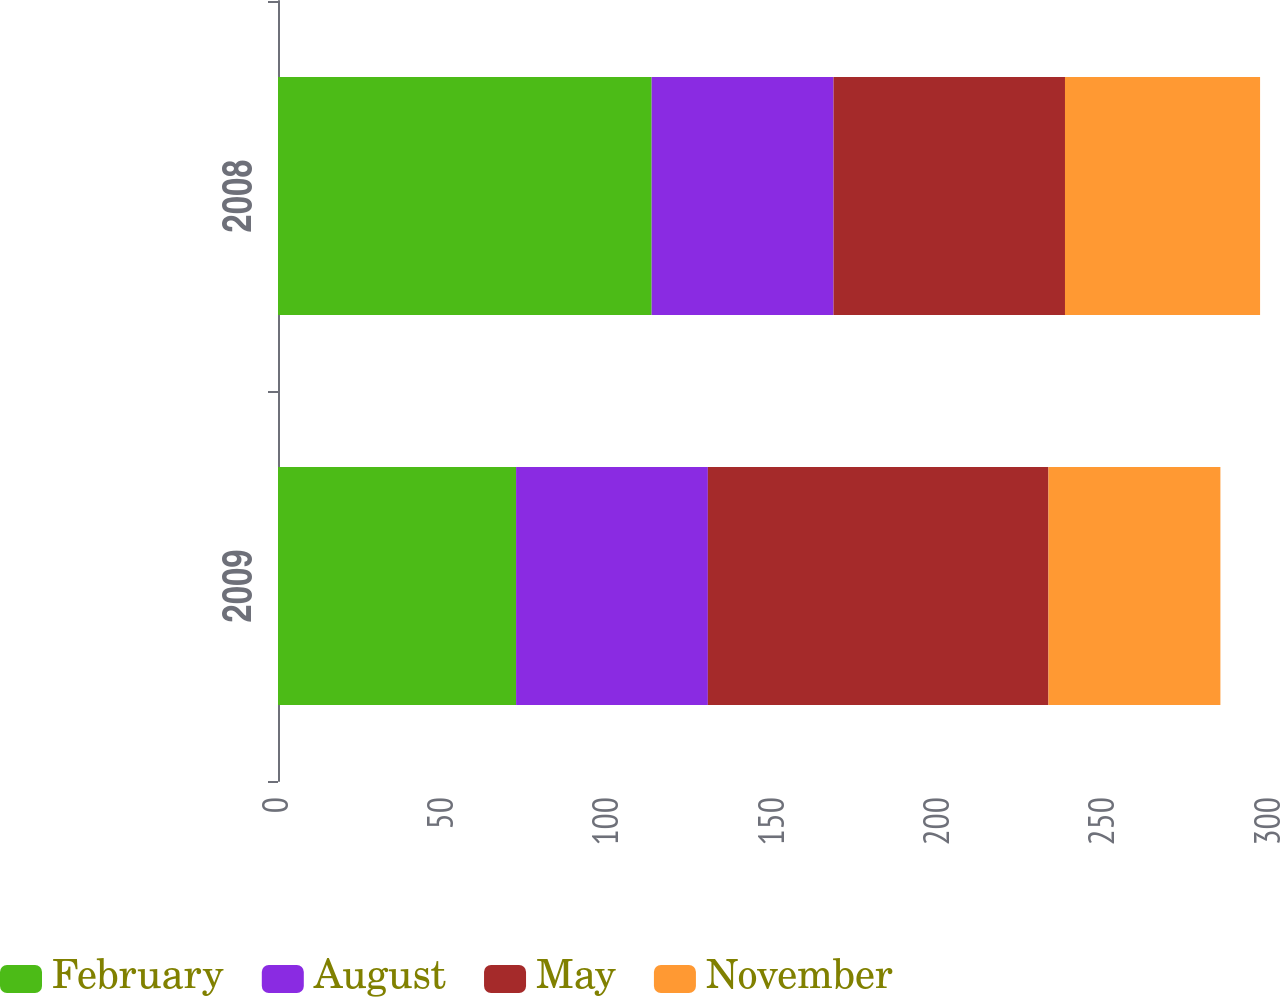<chart> <loc_0><loc_0><loc_500><loc_500><stacked_bar_chart><ecel><fcel>2009<fcel>2008<nl><fcel>February<fcel>72<fcel>113<nl><fcel>August<fcel>58<fcel>55<nl><fcel>May<fcel>103<fcel>70<nl><fcel>November<fcel>52<fcel>59<nl></chart> 